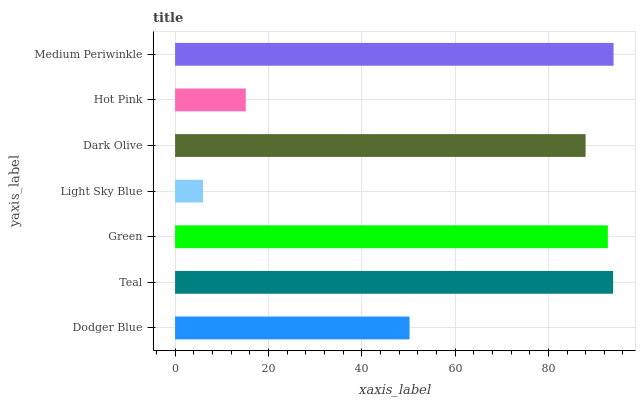Is Light Sky Blue the minimum?
Answer yes or no. Yes. Is Medium Periwinkle the maximum?
Answer yes or no. Yes. Is Teal the minimum?
Answer yes or no. No. Is Teal the maximum?
Answer yes or no. No. Is Teal greater than Dodger Blue?
Answer yes or no. Yes. Is Dodger Blue less than Teal?
Answer yes or no. Yes. Is Dodger Blue greater than Teal?
Answer yes or no. No. Is Teal less than Dodger Blue?
Answer yes or no. No. Is Dark Olive the high median?
Answer yes or no. Yes. Is Dark Olive the low median?
Answer yes or no. Yes. Is Dodger Blue the high median?
Answer yes or no. No. Is Light Sky Blue the low median?
Answer yes or no. No. 